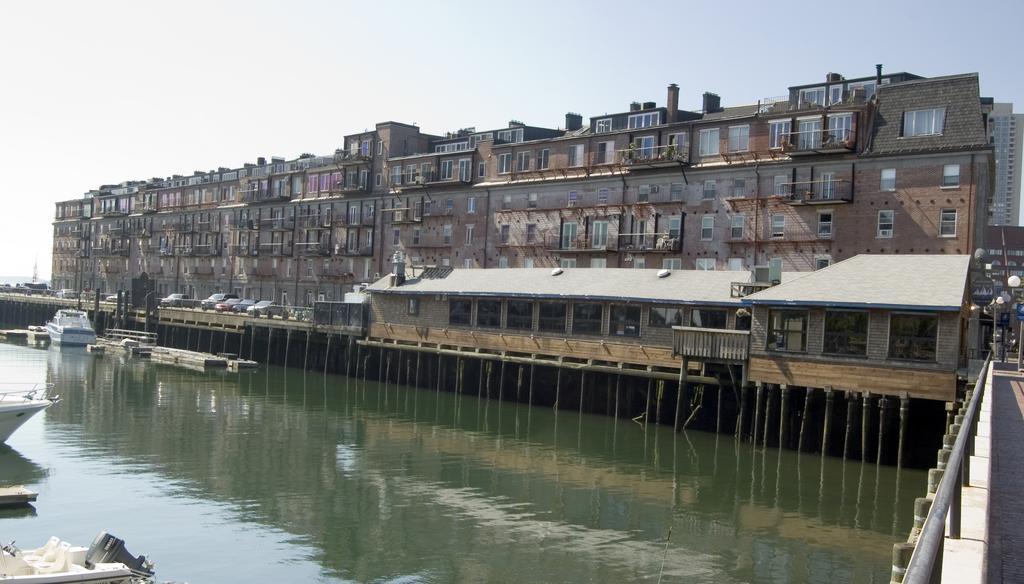Please provide a concise description of this image. This picture shows buildings and we see cars parked and few boats in the water and we see pole lights and a cloudy sky. 